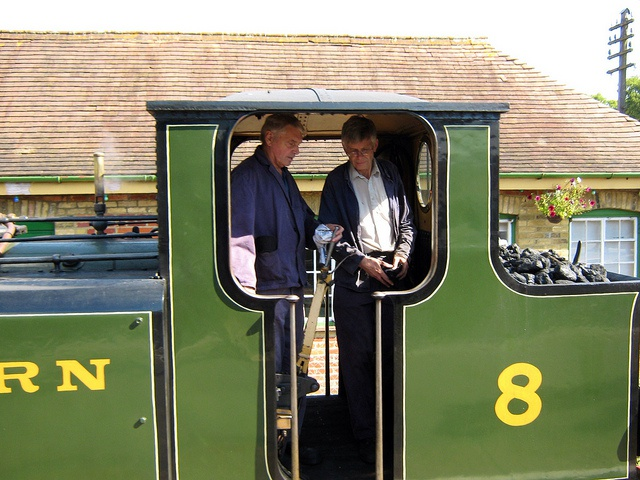Describe the objects in this image and their specific colors. I can see train in white, darkgreen, and black tones, people in white, black, darkgray, and maroon tones, people in white, black, navy, and maroon tones, potted plant in white, olive, and khaki tones, and cell phone in white, black, gray, and maroon tones in this image. 